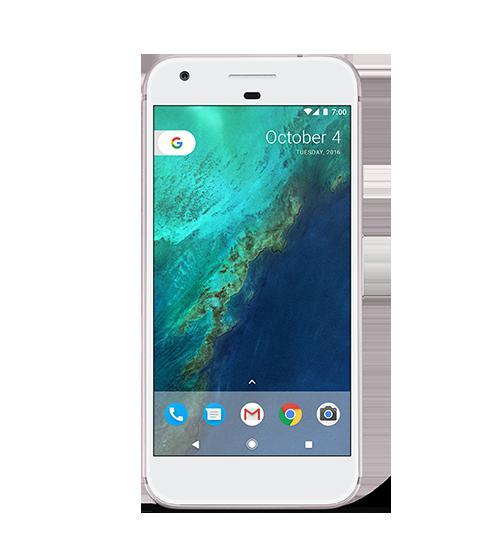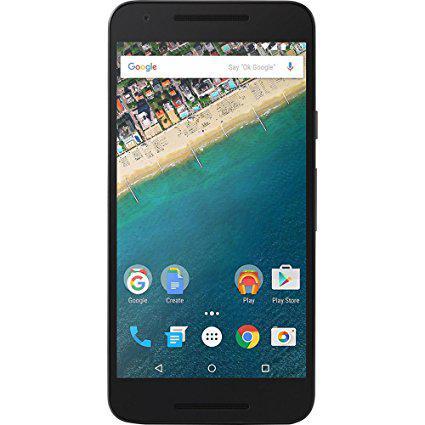The first image is the image on the left, the second image is the image on the right. Given the left and right images, does the statement "The right image contains one smart phone with a black screen." hold true? Answer yes or no. No. The first image is the image on the left, the second image is the image on the right. Considering the images on both sides, is "One of the phones is turned off, with a blank screen." valid? Answer yes or no. No. 